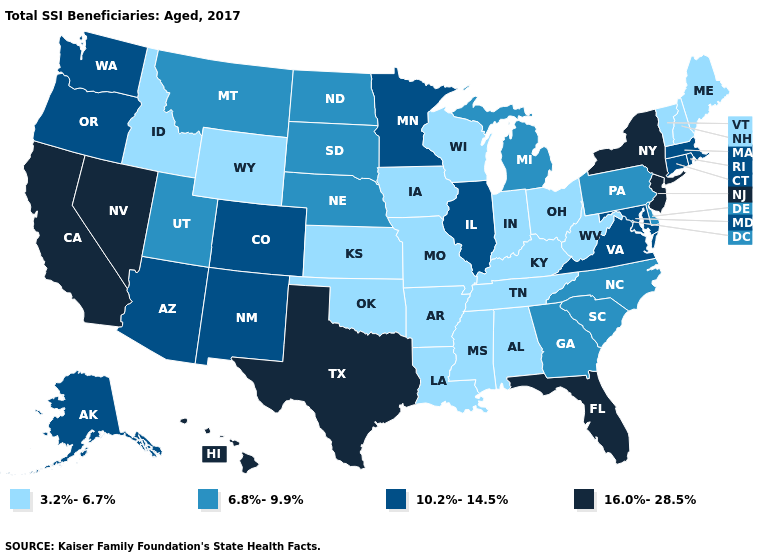Name the states that have a value in the range 16.0%-28.5%?
Write a very short answer. California, Florida, Hawaii, Nevada, New Jersey, New York, Texas. Does Alaska have a higher value than Arkansas?
Quick response, please. Yes. What is the lowest value in states that border Kansas?
Be succinct. 3.2%-6.7%. Which states have the lowest value in the South?
Quick response, please. Alabama, Arkansas, Kentucky, Louisiana, Mississippi, Oklahoma, Tennessee, West Virginia. Does Nebraska have the highest value in the MidWest?
Keep it brief. No. Does Florida have the highest value in the USA?
Answer briefly. Yes. Among the states that border Virginia , which have the lowest value?
Short answer required. Kentucky, Tennessee, West Virginia. Does Nevada have the highest value in the West?
Answer briefly. Yes. Does Illinois have the highest value in the MidWest?
Give a very brief answer. Yes. Does New York have the highest value in the Northeast?
Keep it brief. Yes. Among the states that border Nevada , does Idaho have the highest value?
Answer briefly. No. What is the value of Maryland?
Concise answer only. 10.2%-14.5%. What is the lowest value in the USA?
Concise answer only. 3.2%-6.7%. Which states hav the highest value in the MidWest?
Concise answer only. Illinois, Minnesota. Name the states that have a value in the range 10.2%-14.5%?
Give a very brief answer. Alaska, Arizona, Colorado, Connecticut, Illinois, Maryland, Massachusetts, Minnesota, New Mexico, Oregon, Rhode Island, Virginia, Washington. 